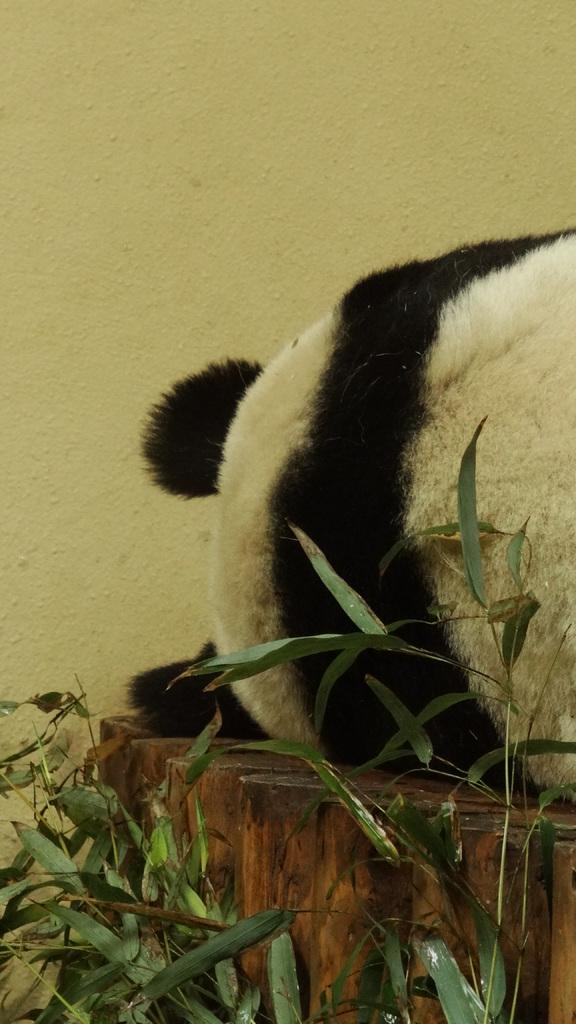What animal is present in the image? There is a panda in the image. What is the panda laying on? The panda is laying on a wooden surface. What can be seen beside the panda? There are leaves of plants beside the panda. What type of tax is the panda paying in the image? There is no indication of any tax in the image; it simply features a panda laying on a wooden surface with leaves of plants beside it. 